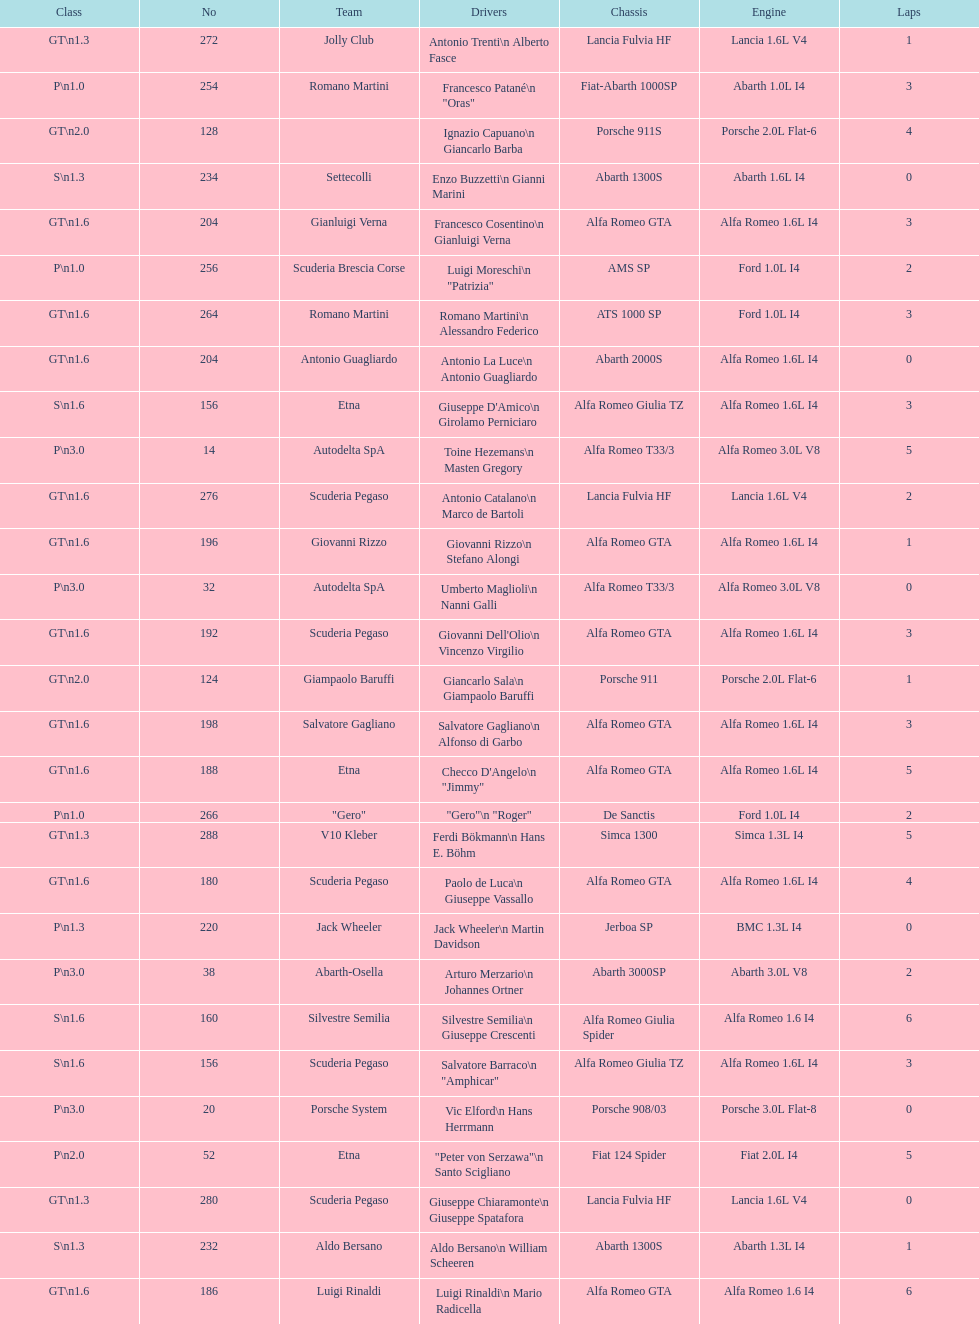How many teams failed to finish the race after 2 laps? 4. 